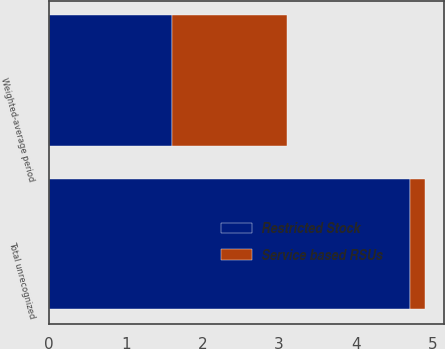<chart> <loc_0><loc_0><loc_500><loc_500><stacked_bar_chart><ecel><fcel>Total unrecognized<fcel>Weighted-average period<nl><fcel>Service based RSUs<fcel>0.2<fcel>1.5<nl><fcel>Restricted Stock<fcel>4.7<fcel>1.6<nl></chart> 